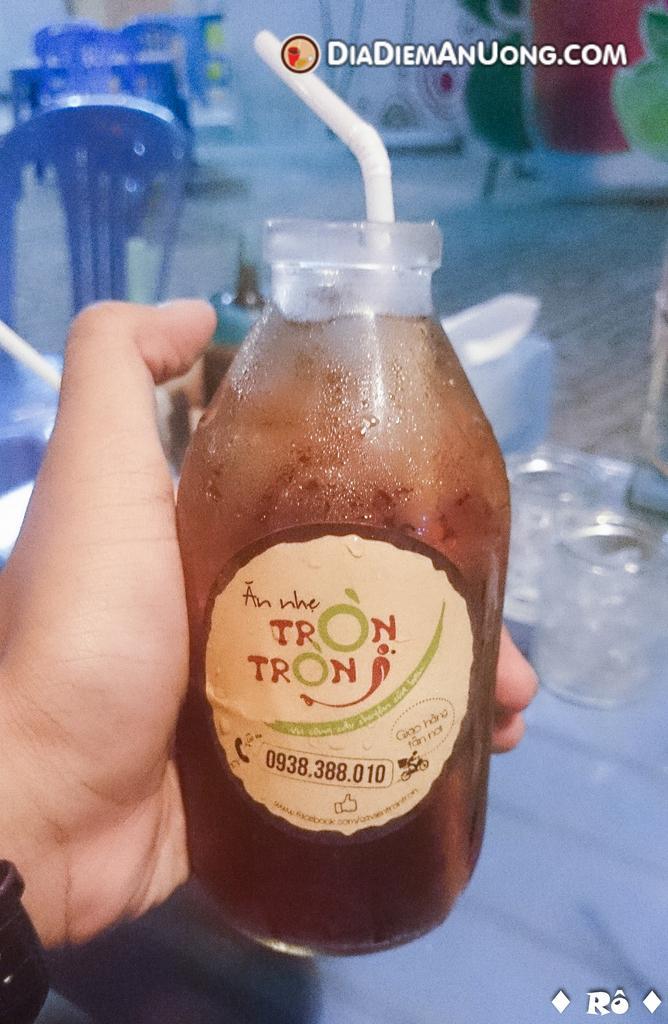Could you give a brief overview of what you see in this image? In this picture we can see bottle and in the bottle we have drink straw in it and the person holding this bottle and in the background we can see chairs, glasses, wall with painting. 